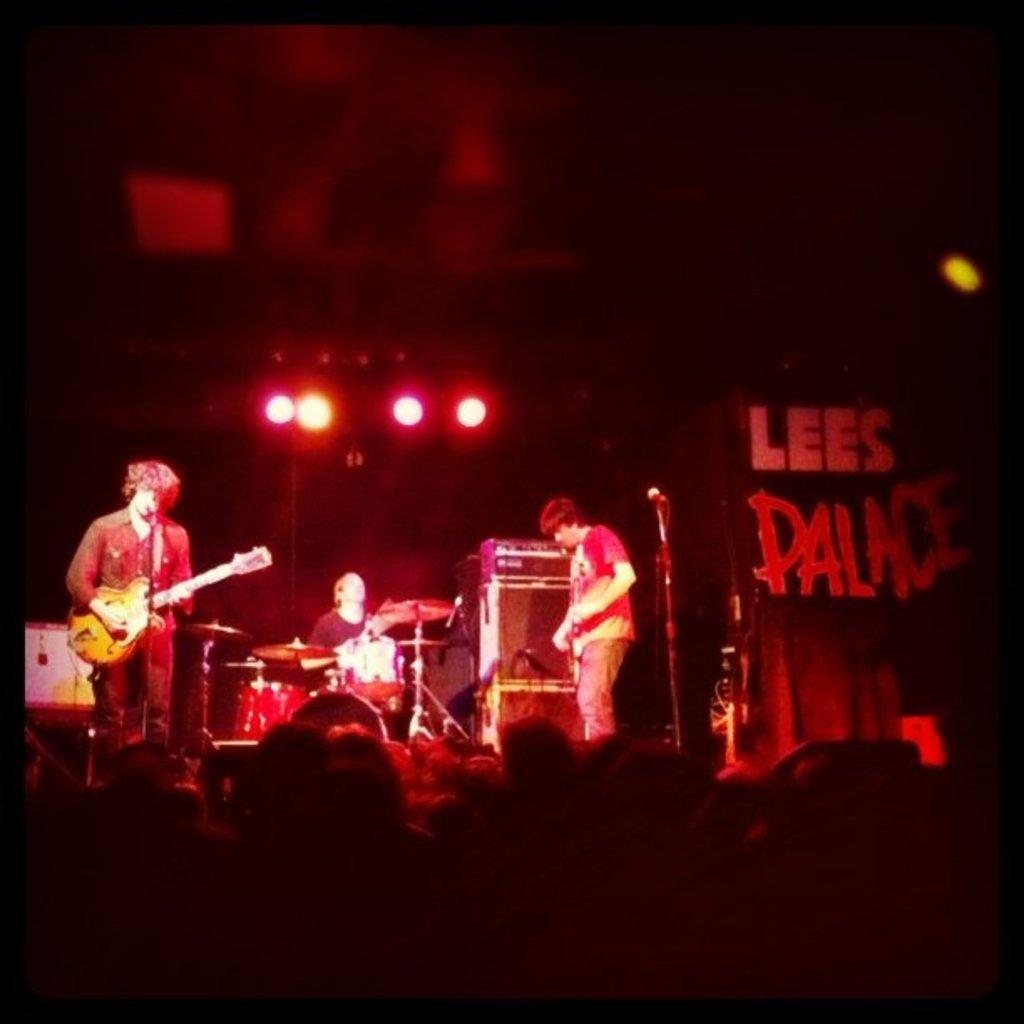Could you give a brief overview of what you see in this image? in the picture there are three persons playing different musical instruments. 